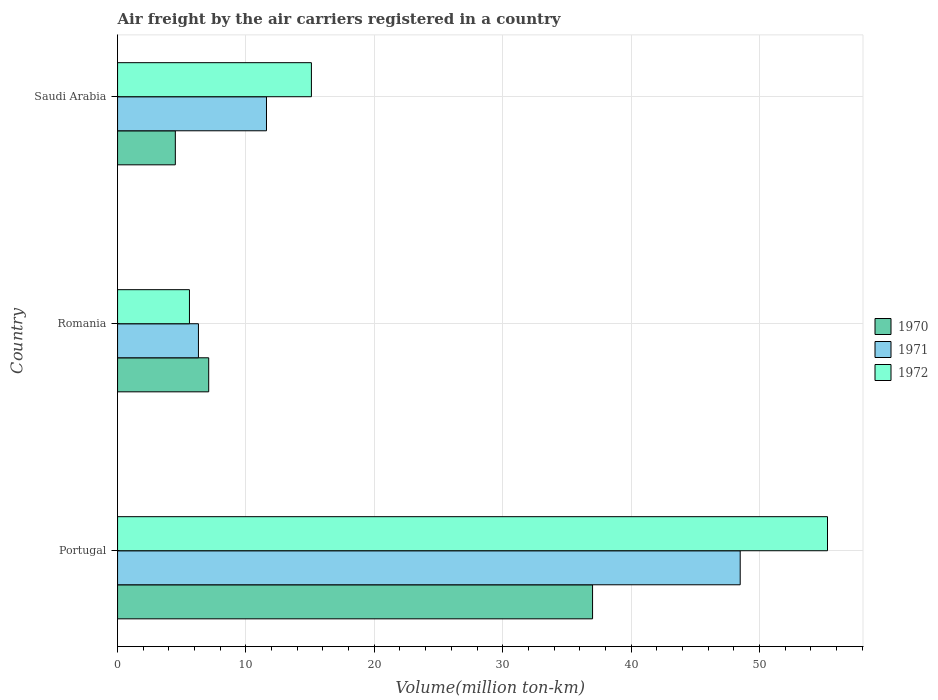How many groups of bars are there?
Your answer should be compact. 3. Are the number of bars per tick equal to the number of legend labels?
Give a very brief answer. Yes. Are the number of bars on each tick of the Y-axis equal?
Ensure brevity in your answer.  Yes. How many bars are there on the 3rd tick from the top?
Provide a succinct answer. 3. What is the label of the 2nd group of bars from the top?
Your response must be concise. Romania. In how many cases, is the number of bars for a given country not equal to the number of legend labels?
Offer a very short reply. 0. What is the volume of the air carriers in 1970 in Romania?
Offer a very short reply. 7.1. Across all countries, what is the maximum volume of the air carriers in 1971?
Keep it short and to the point. 48.5. Across all countries, what is the minimum volume of the air carriers in 1970?
Offer a very short reply. 4.5. In which country was the volume of the air carriers in 1971 maximum?
Offer a very short reply. Portugal. In which country was the volume of the air carriers in 1972 minimum?
Ensure brevity in your answer.  Romania. What is the total volume of the air carriers in 1972 in the graph?
Your answer should be compact. 76. What is the difference between the volume of the air carriers in 1972 in Portugal and that in Romania?
Offer a terse response. 49.7. What is the difference between the volume of the air carriers in 1970 in Romania and the volume of the air carriers in 1972 in Portugal?
Provide a succinct answer. -48.2. What is the average volume of the air carriers in 1971 per country?
Ensure brevity in your answer.  22.13. What is the difference between the volume of the air carriers in 1970 and volume of the air carriers in 1971 in Romania?
Make the answer very short. 0.8. In how many countries, is the volume of the air carriers in 1970 greater than 28 million ton-km?
Provide a succinct answer. 1. What is the ratio of the volume of the air carriers in 1971 in Portugal to that in Romania?
Offer a very short reply. 7.7. Is the difference between the volume of the air carriers in 1970 in Portugal and Saudi Arabia greater than the difference between the volume of the air carriers in 1971 in Portugal and Saudi Arabia?
Your response must be concise. No. What is the difference between the highest and the second highest volume of the air carriers in 1971?
Give a very brief answer. 36.9. What is the difference between the highest and the lowest volume of the air carriers in 1972?
Provide a succinct answer. 49.7. In how many countries, is the volume of the air carriers in 1972 greater than the average volume of the air carriers in 1972 taken over all countries?
Give a very brief answer. 1. What does the 2nd bar from the top in Saudi Arabia represents?
Your answer should be very brief. 1971. How many bars are there?
Offer a very short reply. 9. Are all the bars in the graph horizontal?
Provide a succinct answer. Yes. What is the difference between two consecutive major ticks on the X-axis?
Provide a short and direct response. 10. Are the values on the major ticks of X-axis written in scientific E-notation?
Offer a very short reply. No. Where does the legend appear in the graph?
Provide a short and direct response. Center right. How are the legend labels stacked?
Give a very brief answer. Vertical. What is the title of the graph?
Offer a very short reply. Air freight by the air carriers registered in a country. What is the label or title of the X-axis?
Keep it short and to the point. Volume(million ton-km). What is the Volume(million ton-km) in 1971 in Portugal?
Provide a short and direct response. 48.5. What is the Volume(million ton-km) of 1972 in Portugal?
Ensure brevity in your answer.  55.3. What is the Volume(million ton-km) in 1970 in Romania?
Give a very brief answer. 7.1. What is the Volume(million ton-km) of 1971 in Romania?
Offer a terse response. 6.3. What is the Volume(million ton-km) of 1972 in Romania?
Offer a very short reply. 5.6. What is the Volume(million ton-km) in 1970 in Saudi Arabia?
Your answer should be compact. 4.5. What is the Volume(million ton-km) of 1971 in Saudi Arabia?
Provide a short and direct response. 11.6. What is the Volume(million ton-km) of 1972 in Saudi Arabia?
Give a very brief answer. 15.1. Across all countries, what is the maximum Volume(million ton-km) in 1971?
Provide a short and direct response. 48.5. Across all countries, what is the maximum Volume(million ton-km) of 1972?
Offer a very short reply. 55.3. Across all countries, what is the minimum Volume(million ton-km) of 1971?
Give a very brief answer. 6.3. Across all countries, what is the minimum Volume(million ton-km) of 1972?
Provide a succinct answer. 5.6. What is the total Volume(million ton-km) of 1970 in the graph?
Your answer should be very brief. 48.6. What is the total Volume(million ton-km) in 1971 in the graph?
Your response must be concise. 66.4. What is the total Volume(million ton-km) in 1972 in the graph?
Your response must be concise. 76. What is the difference between the Volume(million ton-km) of 1970 in Portugal and that in Romania?
Your answer should be very brief. 29.9. What is the difference between the Volume(million ton-km) of 1971 in Portugal and that in Romania?
Keep it short and to the point. 42.2. What is the difference between the Volume(million ton-km) in 1972 in Portugal and that in Romania?
Give a very brief answer. 49.7. What is the difference between the Volume(million ton-km) in 1970 in Portugal and that in Saudi Arabia?
Your response must be concise. 32.5. What is the difference between the Volume(million ton-km) in 1971 in Portugal and that in Saudi Arabia?
Make the answer very short. 36.9. What is the difference between the Volume(million ton-km) in 1972 in Portugal and that in Saudi Arabia?
Make the answer very short. 40.2. What is the difference between the Volume(million ton-km) of 1970 in Romania and that in Saudi Arabia?
Provide a short and direct response. 2.6. What is the difference between the Volume(million ton-km) of 1971 in Romania and that in Saudi Arabia?
Provide a succinct answer. -5.3. What is the difference between the Volume(million ton-km) of 1970 in Portugal and the Volume(million ton-km) of 1971 in Romania?
Keep it short and to the point. 30.7. What is the difference between the Volume(million ton-km) in 1970 in Portugal and the Volume(million ton-km) in 1972 in Romania?
Ensure brevity in your answer.  31.4. What is the difference between the Volume(million ton-km) of 1971 in Portugal and the Volume(million ton-km) of 1972 in Romania?
Your answer should be very brief. 42.9. What is the difference between the Volume(million ton-km) in 1970 in Portugal and the Volume(million ton-km) in 1971 in Saudi Arabia?
Offer a very short reply. 25.4. What is the difference between the Volume(million ton-km) in 1970 in Portugal and the Volume(million ton-km) in 1972 in Saudi Arabia?
Offer a terse response. 21.9. What is the difference between the Volume(million ton-km) of 1971 in Portugal and the Volume(million ton-km) of 1972 in Saudi Arabia?
Your answer should be compact. 33.4. What is the difference between the Volume(million ton-km) of 1970 in Romania and the Volume(million ton-km) of 1971 in Saudi Arabia?
Your answer should be compact. -4.5. What is the difference between the Volume(million ton-km) of 1971 in Romania and the Volume(million ton-km) of 1972 in Saudi Arabia?
Keep it short and to the point. -8.8. What is the average Volume(million ton-km) in 1971 per country?
Offer a very short reply. 22.13. What is the average Volume(million ton-km) in 1972 per country?
Offer a very short reply. 25.33. What is the difference between the Volume(million ton-km) of 1970 and Volume(million ton-km) of 1971 in Portugal?
Your answer should be very brief. -11.5. What is the difference between the Volume(million ton-km) in 1970 and Volume(million ton-km) in 1972 in Portugal?
Provide a succinct answer. -18.3. What is the difference between the Volume(million ton-km) of 1970 and Volume(million ton-km) of 1971 in Saudi Arabia?
Ensure brevity in your answer.  -7.1. What is the difference between the Volume(million ton-km) of 1970 and Volume(million ton-km) of 1972 in Saudi Arabia?
Offer a very short reply. -10.6. What is the ratio of the Volume(million ton-km) in 1970 in Portugal to that in Romania?
Offer a terse response. 5.21. What is the ratio of the Volume(million ton-km) in 1971 in Portugal to that in Romania?
Give a very brief answer. 7.7. What is the ratio of the Volume(million ton-km) in 1972 in Portugal to that in Romania?
Offer a very short reply. 9.88. What is the ratio of the Volume(million ton-km) of 1970 in Portugal to that in Saudi Arabia?
Make the answer very short. 8.22. What is the ratio of the Volume(million ton-km) of 1971 in Portugal to that in Saudi Arabia?
Offer a very short reply. 4.18. What is the ratio of the Volume(million ton-km) in 1972 in Portugal to that in Saudi Arabia?
Make the answer very short. 3.66. What is the ratio of the Volume(million ton-km) in 1970 in Romania to that in Saudi Arabia?
Give a very brief answer. 1.58. What is the ratio of the Volume(million ton-km) of 1971 in Romania to that in Saudi Arabia?
Your answer should be very brief. 0.54. What is the ratio of the Volume(million ton-km) in 1972 in Romania to that in Saudi Arabia?
Keep it short and to the point. 0.37. What is the difference between the highest and the second highest Volume(million ton-km) of 1970?
Make the answer very short. 29.9. What is the difference between the highest and the second highest Volume(million ton-km) in 1971?
Offer a terse response. 36.9. What is the difference between the highest and the second highest Volume(million ton-km) of 1972?
Ensure brevity in your answer.  40.2. What is the difference between the highest and the lowest Volume(million ton-km) of 1970?
Keep it short and to the point. 32.5. What is the difference between the highest and the lowest Volume(million ton-km) in 1971?
Your answer should be compact. 42.2. What is the difference between the highest and the lowest Volume(million ton-km) in 1972?
Ensure brevity in your answer.  49.7. 